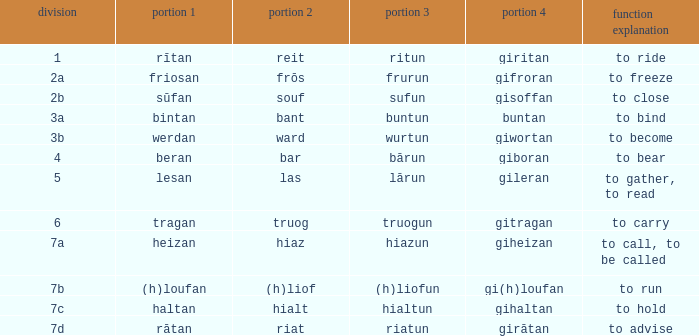What is the verb meaning of the word with part 2 "bant"? To bind. 